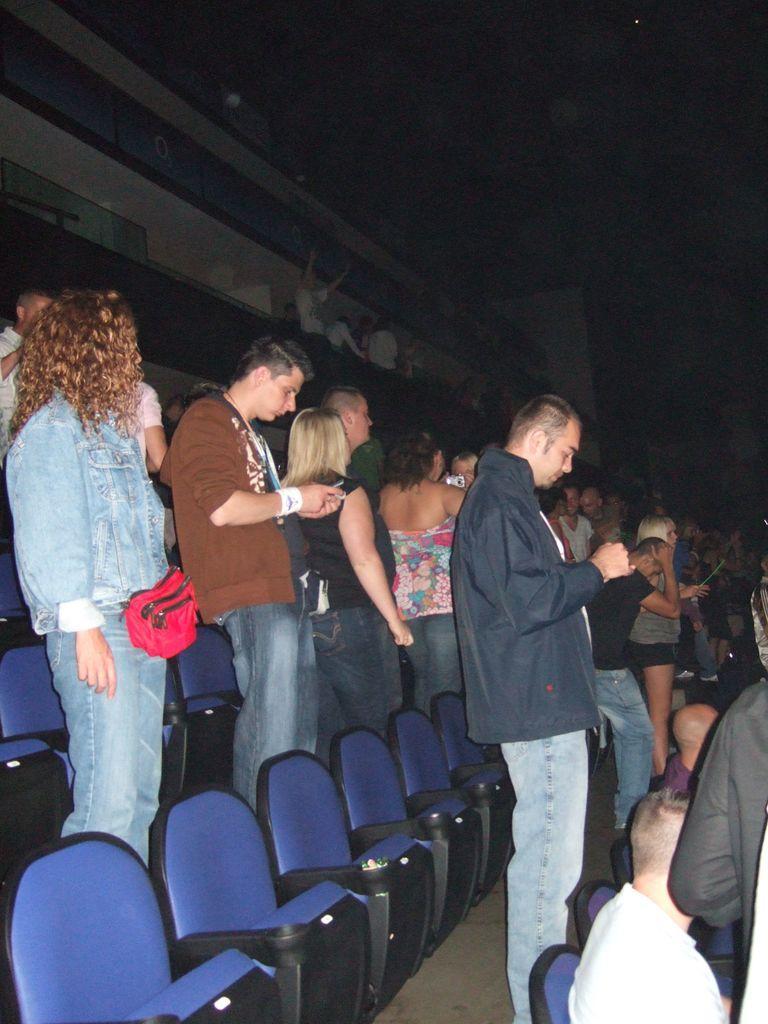Can you describe this image briefly? In this image we can see that, there are most of them are standing and some of them are operating mobiles and at the bottom left hand corner some of them are sitting on the chair. 